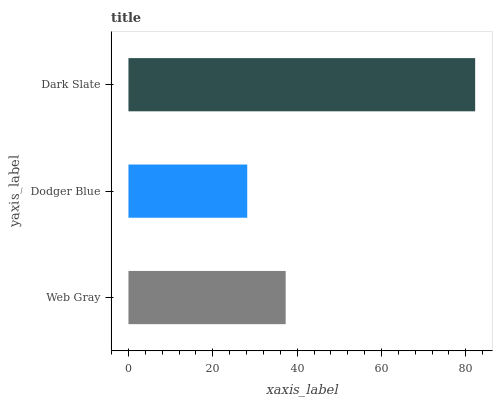Is Dodger Blue the minimum?
Answer yes or no. Yes. Is Dark Slate the maximum?
Answer yes or no. Yes. Is Dark Slate the minimum?
Answer yes or no. No. Is Dodger Blue the maximum?
Answer yes or no. No. Is Dark Slate greater than Dodger Blue?
Answer yes or no. Yes. Is Dodger Blue less than Dark Slate?
Answer yes or no. Yes. Is Dodger Blue greater than Dark Slate?
Answer yes or no. No. Is Dark Slate less than Dodger Blue?
Answer yes or no. No. Is Web Gray the high median?
Answer yes or no. Yes. Is Web Gray the low median?
Answer yes or no. Yes. Is Dark Slate the high median?
Answer yes or no. No. Is Dark Slate the low median?
Answer yes or no. No. 